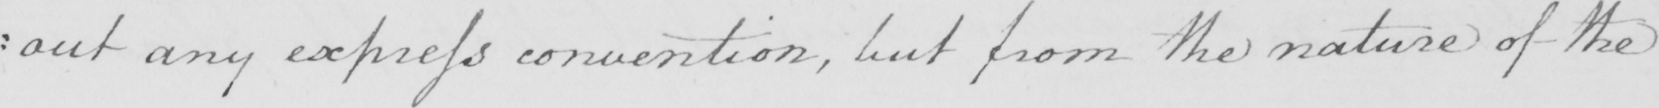Can you read and transcribe this handwriting? : out any express convention , but from the nature of the 